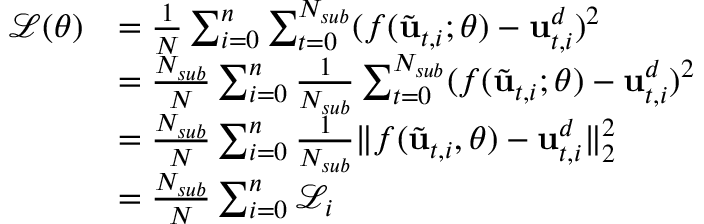<formula> <loc_0><loc_0><loc_500><loc_500>\begin{array} { r l } { \mathcal { L } ( \theta ) } & { = \frac { 1 } { N } \sum _ { i = 0 } ^ { n } \sum _ { t = 0 } ^ { N _ { s u b } } ( f ( \tilde { u } _ { t , i } ; \theta ) - u _ { t , i } ^ { d } ) ^ { 2 } } \\ & { = \frac { N _ { s u b } } { N } \sum _ { i = 0 } ^ { n } { \frac { 1 } { N _ { s u b } } \sum _ { t = 0 } ^ { N _ { s u b } } ( f ( \tilde { u } _ { t , i } ; \theta ) - u _ { t , i } ^ { d } ) ^ { 2 } } } \\ & { = \frac { N _ { s u b } } { N } \sum _ { i = 0 } ^ { n } \frac { 1 } { N _ { s u b } } \| f ( \tilde { u } _ { t , i } , \theta ) - u _ { t , i } ^ { d } \| _ { 2 } ^ { 2 } } \\ & { = \frac { N _ { s u b } } { N } \sum _ { i = 0 } ^ { n } \mathcal { L } _ { i } } \end{array}</formula> 